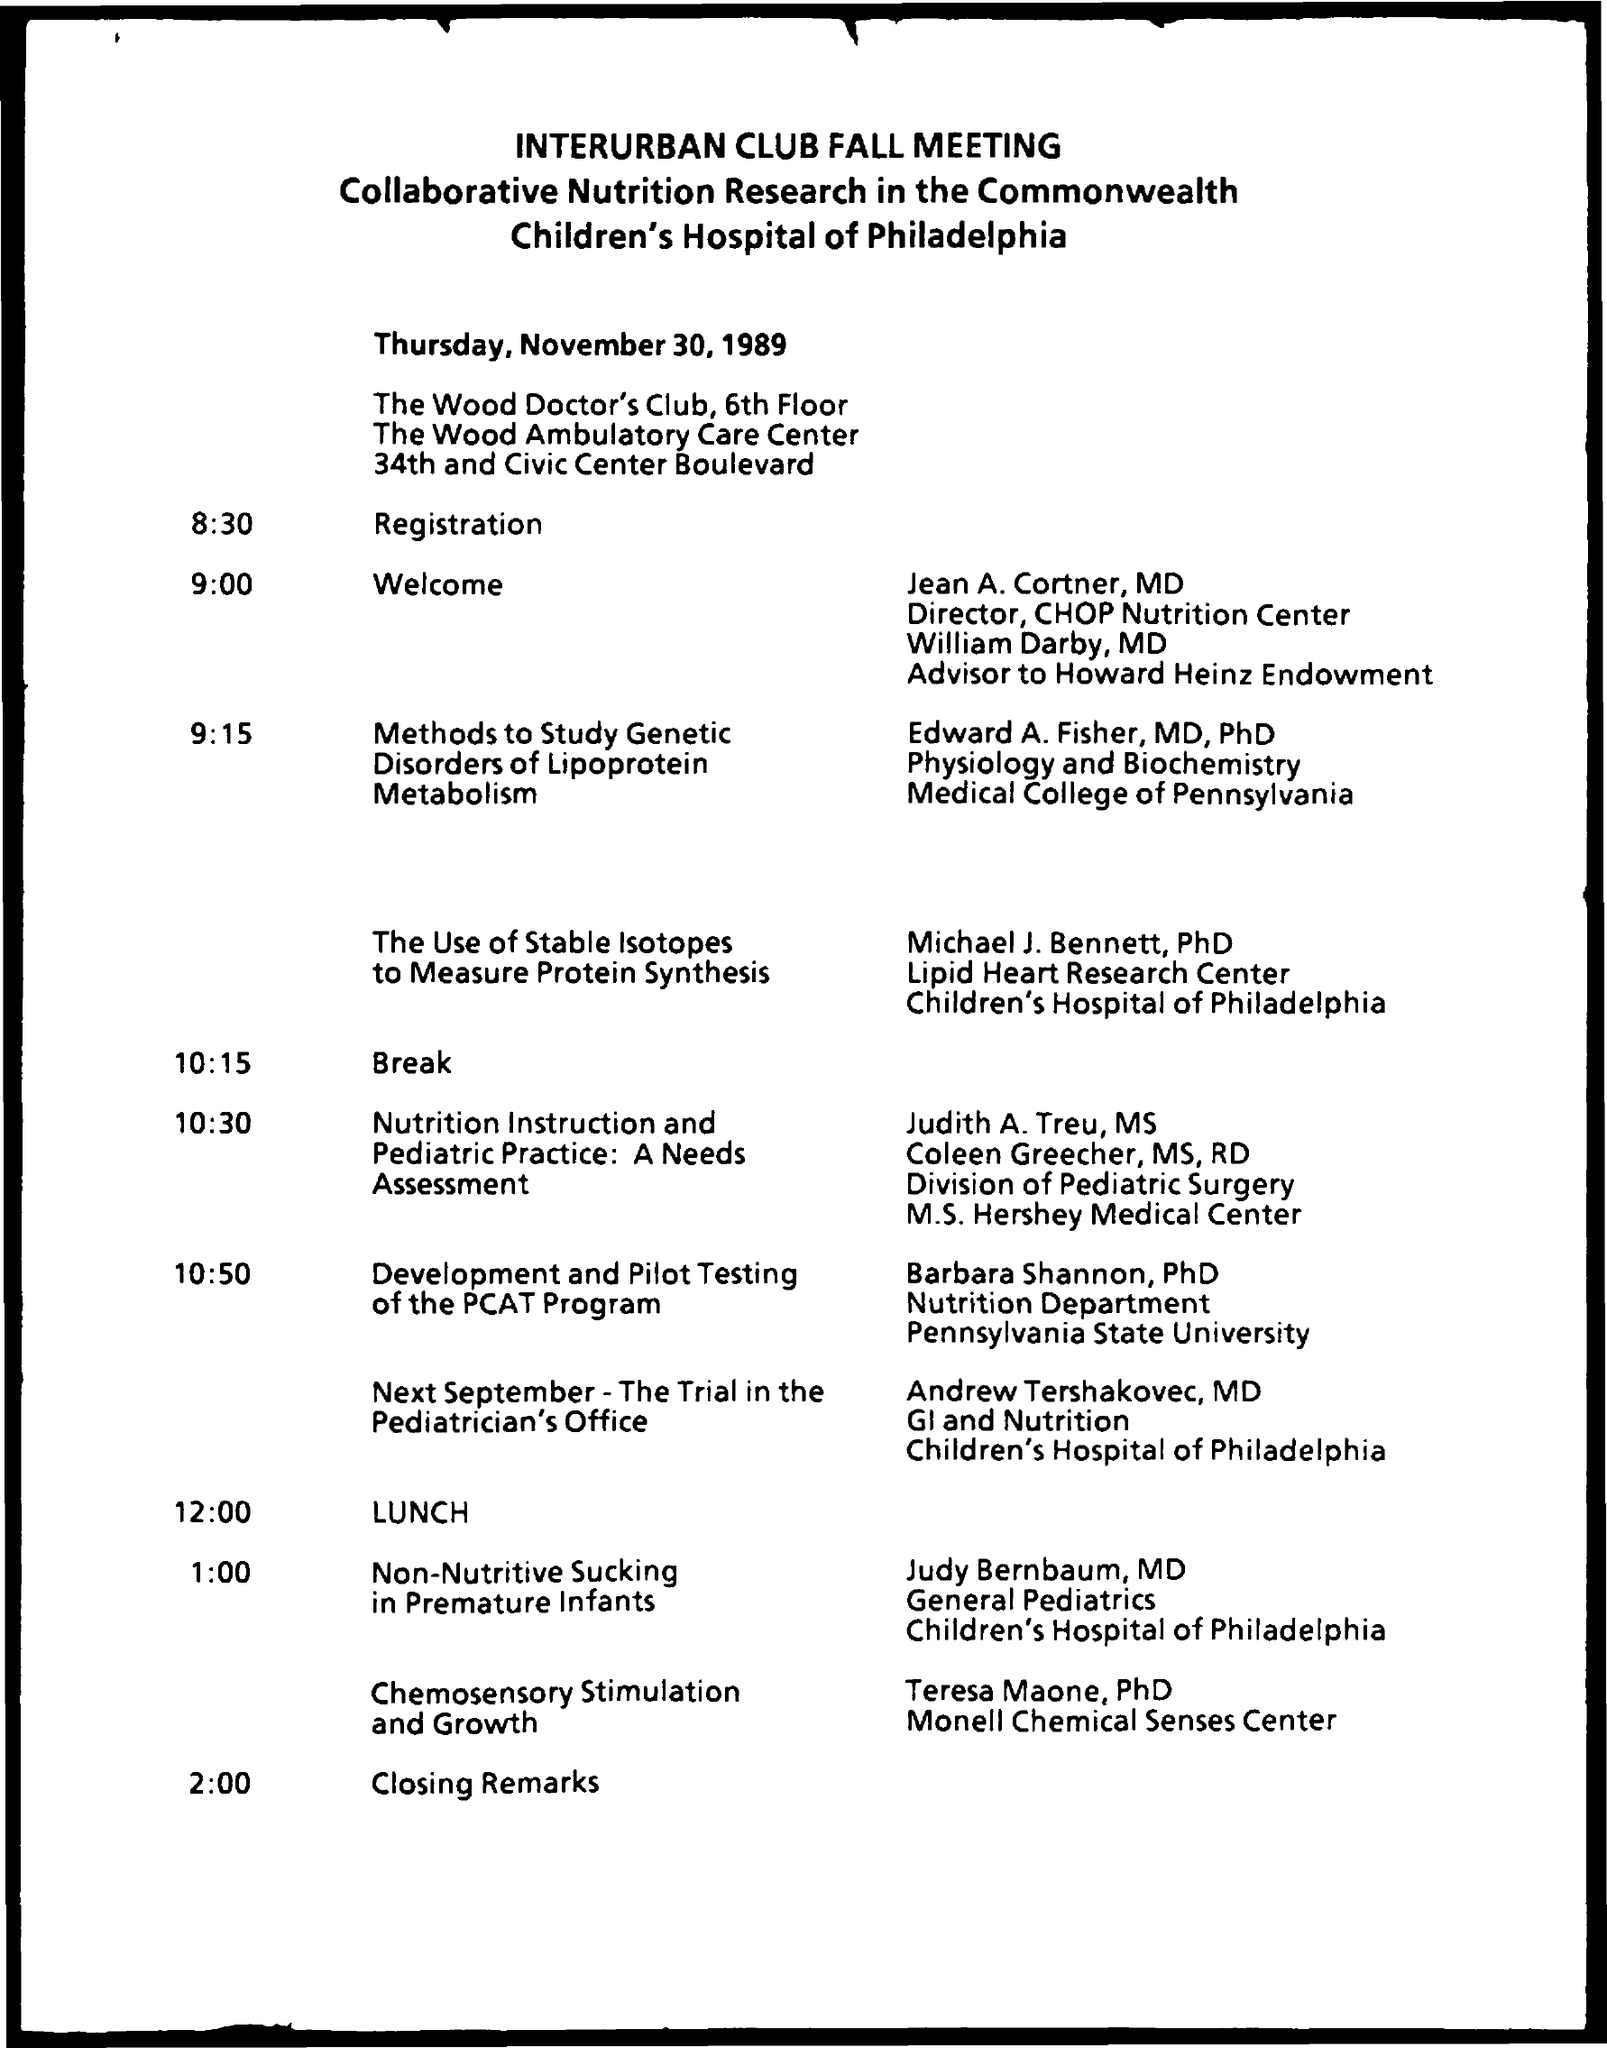what is the given schedule at the time of 9:00 ? At 9:00 AM, according to the schedule, the 'Welcome' address was given by Jean A. Cortner, MD, who is the Director of the CHOP Nutrition Center, and William Darby, MD, who is the Advisor to Howard Heinz Endowment. 